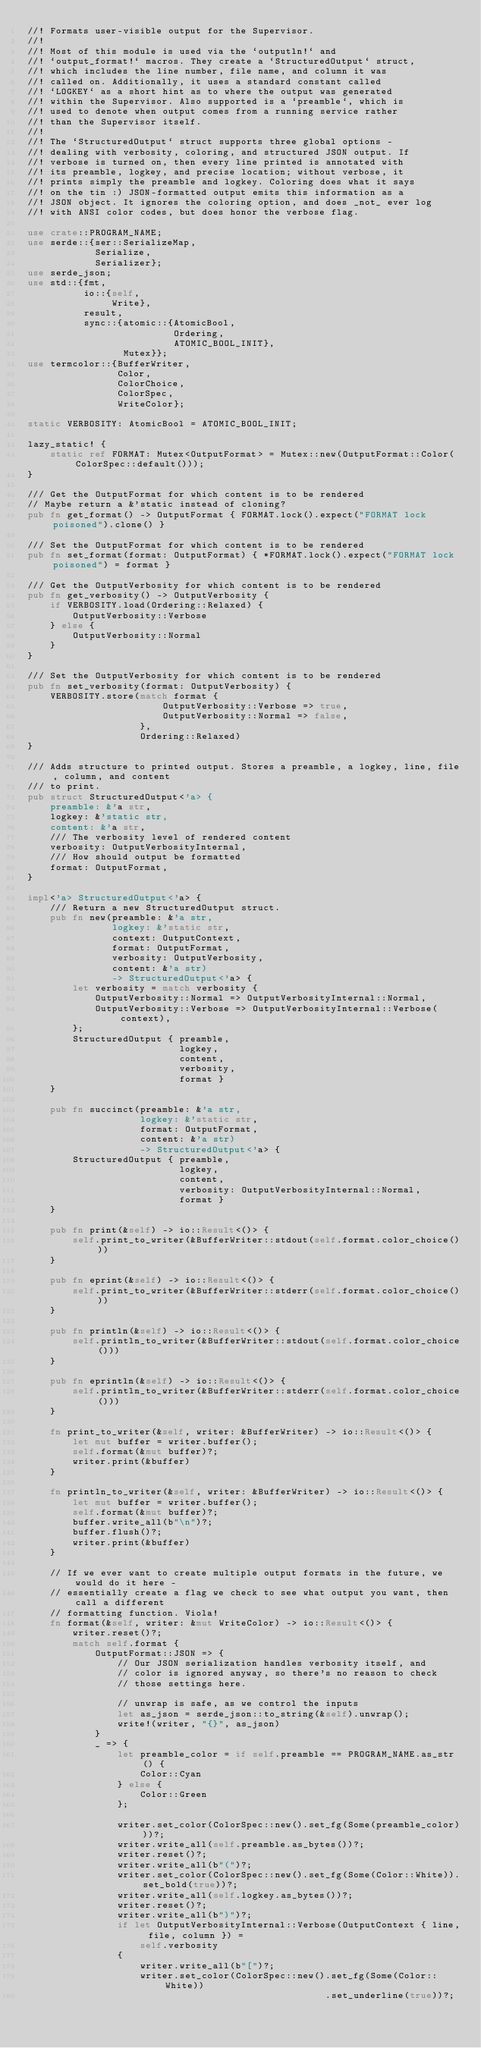<code> <loc_0><loc_0><loc_500><loc_500><_Rust_>//! Formats user-visible output for the Supervisor.
//!
//! Most of this module is used via the `outputln!` and
//! `output_format!` macros. They create a `StructuredOutput` struct,
//! which includes the line number, file name, and column it was
//! called on. Additionally, it uses a standard constant called
//! `LOGKEY` as a short hint as to where the output was generated
//! within the Supervisor. Also supported is a `preamble`, which is
//! used to denote when output comes from a running service rather
//! than the Supervisor itself.
//!
//! The `StructuredOutput` struct supports three global options -
//! dealing with verbosity, coloring, and structured JSON output. If
//! verbose is turned on, then every line printed is annotated with
//! its preamble, logkey, and precise location; without verbose, it
//! prints simply the preamble and logkey. Coloring does what it says
//! on the tin :) JSON-formatted output emits this information as a
//! JSON object. It ignores the coloring option, and does _not_ ever log
//! with ANSI color codes, but does honor the verbose flag.

use crate::PROGRAM_NAME;
use serde::{ser::SerializeMap,
            Serialize,
            Serializer};
use serde_json;
use std::{fmt,
          io::{self,
               Write},
          result,
          sync::{atomic::{AtomicBool,
                          Ordering,
                          ATOMIC_BOOL_INIT},
                 Mutex}};
use termcolor::{BufferWriter,
                Color,
                ColorChoice,
                ColorSpec,
                WriteColor};

static VERBOSITY: AtomicBool = ATOMIC_BOOL_INIT;

lazy_static! {
    static ref FORMAT: Mutex<OutputFormat> = Mutex::new(OutputFormat::Color(ColorSpec::default()));
}

/// Get the OutputFormat for which content is to be rendered
// Maybe return a &'static instead of cloning?
pub fn get_format() -> OutputFormat { FORMAT.lock().expect("FORMAT lock poisoned").clone() }

/// Set the OutputFormat for which content is to be rendered
pub fn set_format(format: OutputFormat) { *FORMAT.lock().expect("FORMAT lock poisoned") = format }

/// Get the OutputVerbosity for which content is to be rendered
pub fn get_verbosity() -> OutputVerbosity {
    if VERBOSITY.load(Ordering::Relaxed) {
        OutputVerbosity::Verbose
    } else {
        OutputVerbosity::Normal
    }
}

/// Set the OutputVerbosity for which content is to be rendered
pub fn set_verbosity(format: OutputVerbosity) {
    VERBOSITY.store(match format {
                        OutputVerbosity::Verbose => true,
                        OutputVerbosity::Normal => false,
                    },
                    Ordering::Relaxed)
}

/// Adds structure to printed output. Stores a preamble, a logkey, line, file, column, and content
/// to print.
pub struct StructuredOutput<'a> {
    preamble: &'a str,
    logkey: &'static str,
    content: &'a str,
    /// The verbosity level of rendered content
    verbosity: OutputVerbosityInternal,
    /// How should output be formatted
    format: OutputFormat,
}

impl<'a> StructuredOutput<'a> {
    /// Return a new StructuredOutput struct.
    pub fn new(preamble: &'a str,
               logkey: &'static str,
               context: OutputContext,
               format: OutputFormat,
               verbosity: OutputVerbosity,
               content: &'a str)
               -> StructuredOutput<'a> {
        let verbosity = match verbosity {
            OutputVerbosity::Normal => OutputVerbosityInternal::Normal,
            OutputVerbosity::Verbose => OutputVerbosityInternal::Verbose(context),
        };
        StructuredOutput { preamble,
                           logkey,
                           content,
                           verbosity,
                           format }
    }

    pub fn succinct(preamble: &'a str,
                    logkey: &'static str,
                    format: OutputFormat,
                    content: &'a str)
                    -> StructuredOutput<'a> {
        StructuredOutput { preamble,
                           logkey,
                           content,
                           verbosity: OutputVerbosityInternal::Normal,
                           format }
    }

    pub fn print(&self) -> io::Result<()> {
        self.print_to_writer(&BufferWriter::stdout(self.format.color_choice()))
    }

    pub fn eprint(&self) -> io::Result<()> {
        self.print_to_writer(&BufferWriter::stderr(self.format.color_choice()))
    }

    pub fn println(&self) -> io::Result<()> {
        self.println_to_writer(&BufferWriter::stdout(self.format.color_choice()))
    }

    pub fn eprintln(&self) -> io::Result<()> {
        self.println_to_writer(&BufferWriter::stderr(self.format.color_choice()))
    }

    fn print_to_writer(&self, writer: &BufferWriter) -> io::Result<()> {
        let mut buffer = writer.buffer();
        self.format(&mut buffer)?;
        writer.print(&buffer)
    }

    fn println_to_writer(&self, writer: &BufferWriter) -> io::Result<()> {
        let mut buffer = writer.buffer();
        self.format(&mut buffer)?;
        buffer.write_all(b"\n")?;
        buffer.flush()?;
        writer.print(&buffer)
    }

    // If we ever want to create multiple output formats in the future, we would do it here -
    // essentially create a flag we check to see what output you want, then call a different
    // formatting function. Viola!
    fn format(&self, writer: &mut WriteColor) -> io::Result<()> {
        writer.reset()?;
        match self.format {
            OutputFormat::JSON => {
                // Our JSON serialization handles verbosity itself, and
                // color is ignored anyway, so there's no reason to check
                // those settings here.

                // unwrap is safe, as we control the inputs
                let as_json = serde_json::to_string(&self).unwrap();
                write!(writer, "{}", as_json)
            }
            _ => {
                let preamble_color = if self.preamble == PROGRAM_NAME.as_str() {
                    Color::Cyan
                } else {
                    Color::Green
                };

                writer.set_color(ColorSpec::new().set_fg(Some(preamble_color)))?;
                writer.write_all(self.preamble.as_bytes())?;
                writer.reset()?;
                writer.write_all(b"(")?;
                writer.set_color(ColorSpec::new().set_fg(Some(Color::White)).set_bold(true))?;
                writer.write_all(self.logkey.as_bytes())?;
                writer.reset()?;
                writer.write_all(b")")?;
                if let OutputVerbosityInternal::Verbose(OutputContext { line, file, column }) =
                    self.verbosity
                {
                    writer.write_all(b"[")?;
                    writer.set_color(ColorSpec::new().set_fg(Some(Color::White))
                                                     .set_underline(true))?;</code> 